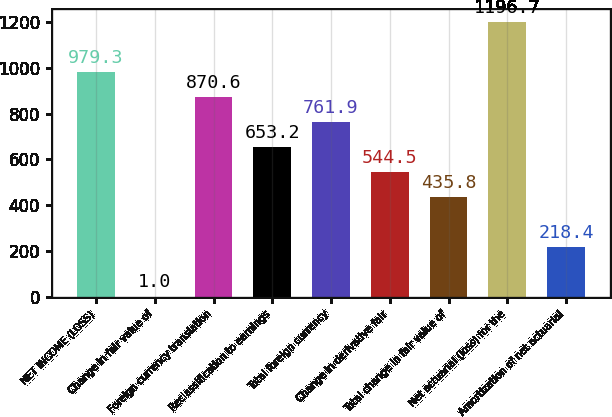Convert chart to OTSL. <chart><loc_0><loc_0><loc_500><loc_500><bar_chart><fcel>NET INCOME (LOSS)<fcel>Change in fair value of<fcel>Foreign currency translation<fcel>Reclassification to earnings<fcel>Total foreign currency<fcel>Change in derivative fair<fcel>Total change in fair value of<fcel>Net actuarial (loss) for the<fcel>Amortization of net actuarial<nl><fcel>979.3<fcel>1<fcel>870.6<fcel>653.2<fcel>761.9<fcel>544.5<fcel>435.8<fcel>1196.7<fcel>218.4<nl></chart> 